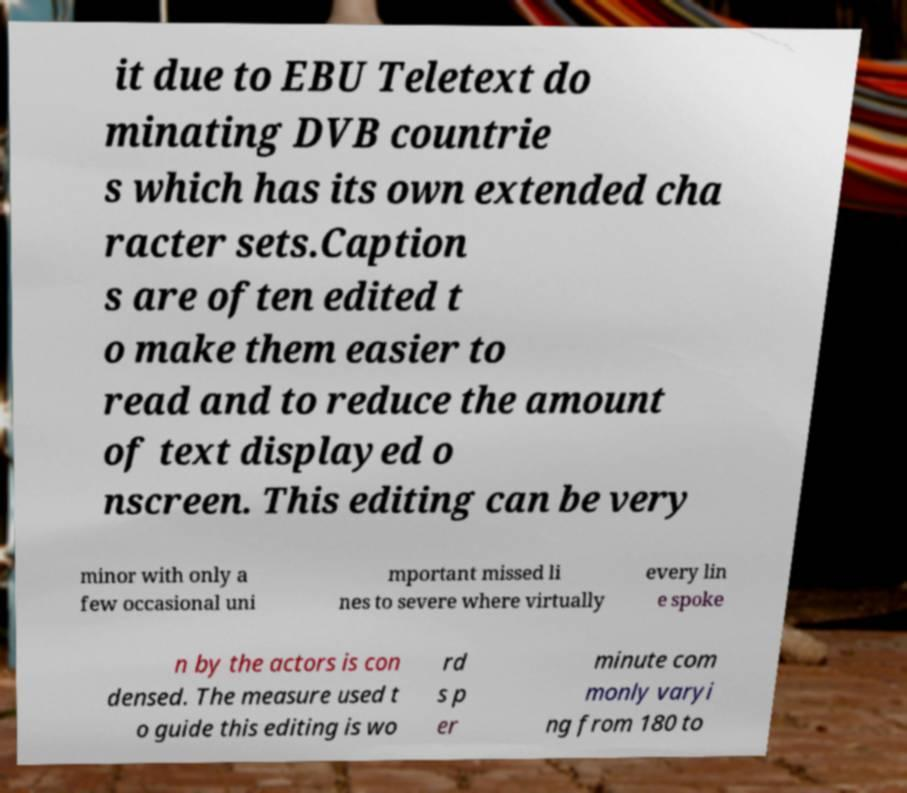What messages or text are displayed in this image? I need them in a readable, typed format. it due to EBU Teletext do minating DVB countrie s which has its own extended cha racter sets.Caption s are often edited t o make them easier to read and to reduce the amount of text displayed o nscreen. This editing can be very minor with only a few occasional uni mportant missed li nes to severe where virtually every lin e spoke n by the actors is con densed. The measure used t o guide this editing is wo rd s p er minute com monly varyi ng from 180 to 